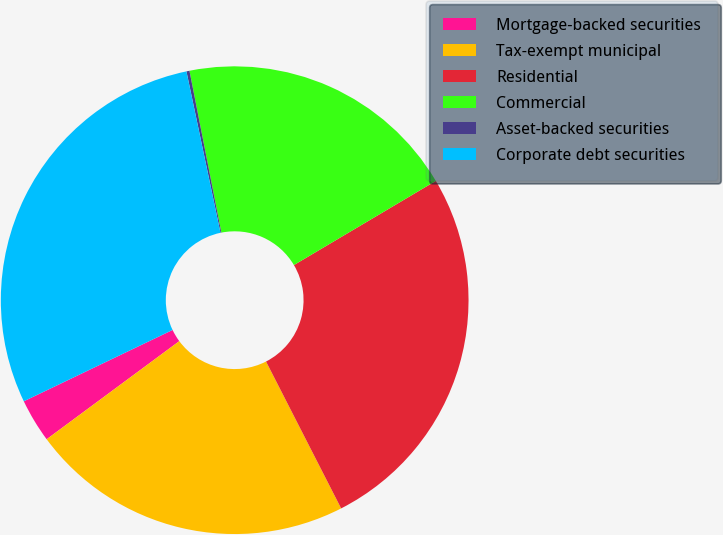Convert chart to OTSL. <chart><loc_0><loc_0><loc_500><loc_500><pie_chart><fcel>Mortgage-backed securities<fcel>Tax-exempt municipal<fcel>Residential<fcel>Commercial<fcel>Asset-backed securities<fcel>Corporate debt securities<nl><fcel>3.02%<fcel>22.39%<fcel>26.0%<fcel>19.58%<fcel>0.21%<fcel>28.81%<nl></chart> 